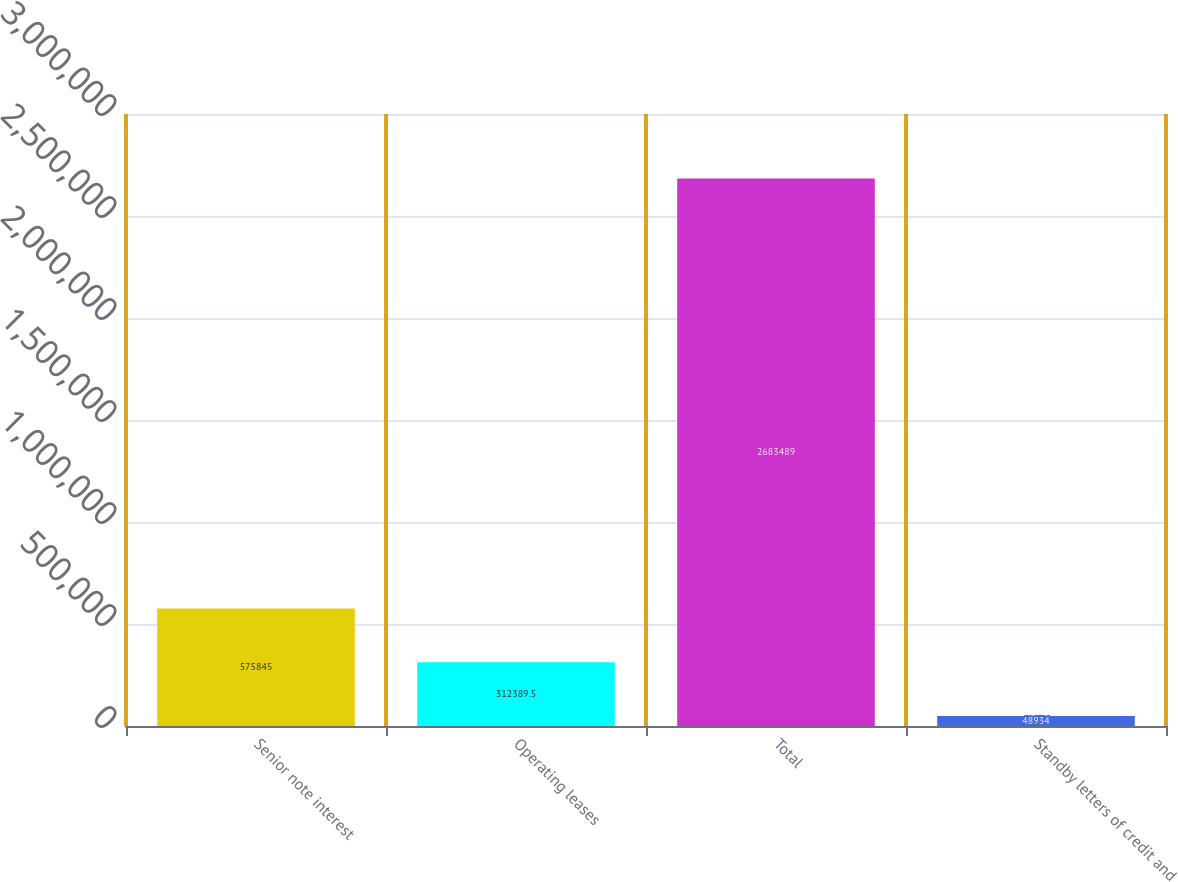Convert chart to OTSL. <chart><loc_0><loc_0><loc_500><loc_500><bar_chart><fcel>Senior note interest<fcel>Operating leases<fcel>Total<fcel>Standby letters of credit and<nl><fcel>575845<fcel>312390<fcel>2.68349e+06<fcel>48934<nl></chart> 